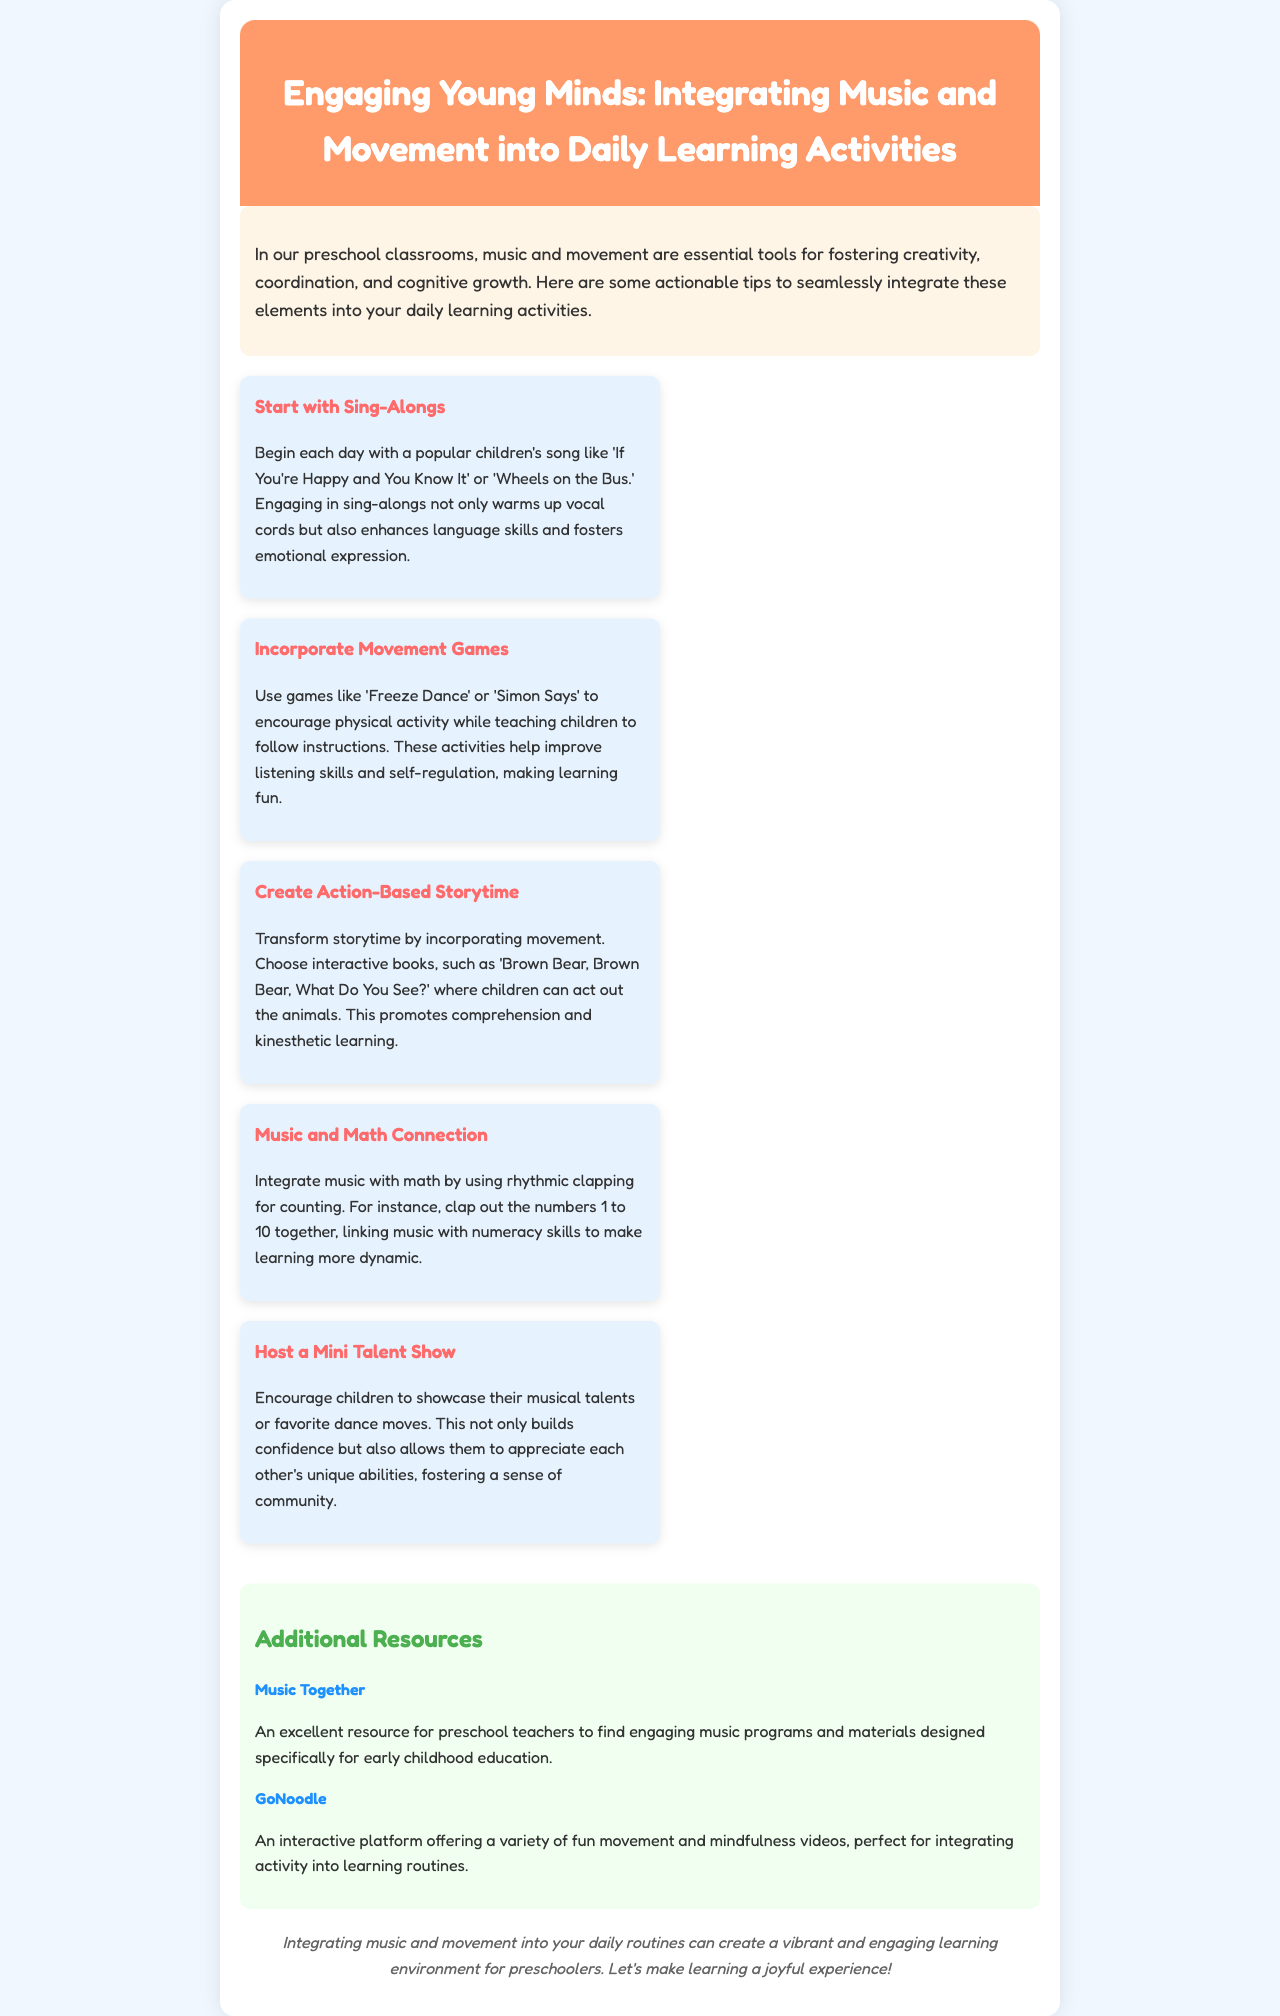What is the title of the newsletter? The title of the newsletter is displayed prominently in the header section of the document.
Answer: Engaging Young Minds: Integrating Music and Movement into Daily Learning Activities What is one suggested song to start the day? The document lists popular children's songs as warm-up activities, indicating examples in a section about sing-alongs.
Answer: If You're Happy and You Know It What activity encourages physical movement? The document mentions games aimed at promoting physical activity while teaching instructions under the movement games tip.
Answer: Freeze Dance Which book is suggested for action-based storytime? The document provides an example of an interactive book suitable for transforming storytime with movement.
Answer: Brown Bear, Brown Bear, What Do You See? How many tips are provided in the document? The document has a section listing different tips, and by counting them, we can find the total.
Answer: Five What type of resource is Music Together? The document categorizes additional resources and specifies what kind of resource each one is.
Answer: Music program What does a mini talent show help build? The document explains the benefits of hosting a mini talent show and what it can foster in children.
Answer: Confidence What is the background color of the document? The background color of the newsletter is specified in the CSS styling section of the document.
Answer: #F0F7FF 